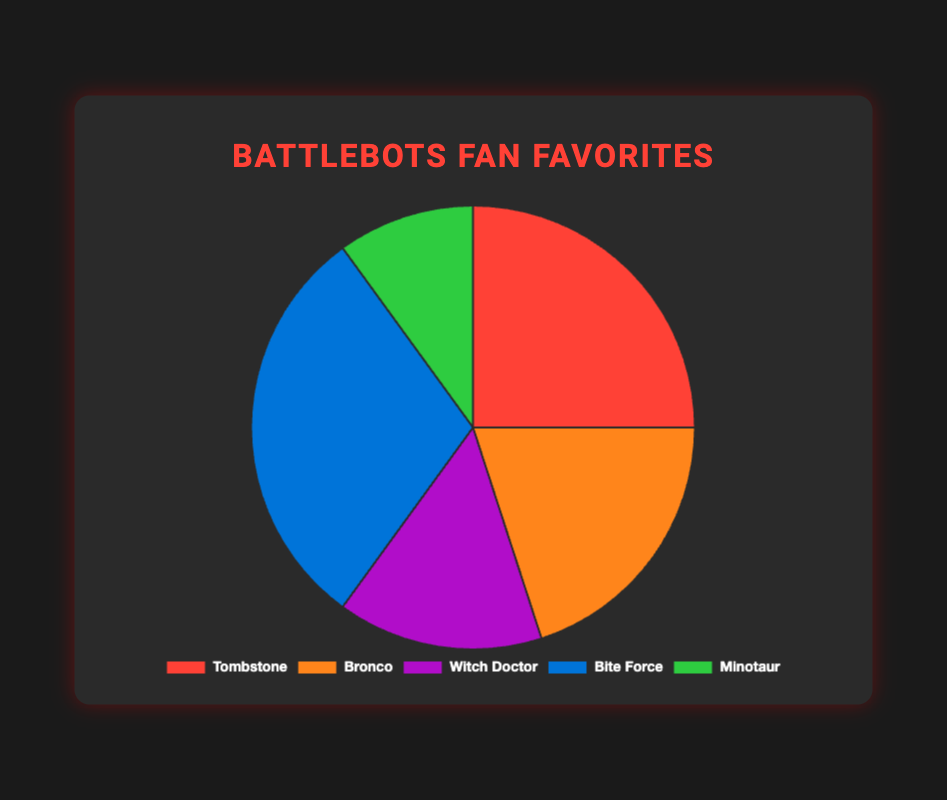what percentage of fans prefer Tombstone over Minotaur? Fans prefer Tombstone and Minotaur by 25% and 10% respectively. To find out how much more, subtract Minotaur's percentage from Tombstone's: 25% - 10% = 15%.
Answer: 15% Which bot is the most popular among fans? The bot with the highest percentage of fans is the most popular. From the data, Bite Force has the highest percentage at 30%.
Answer: Bite Force Which two bots together make up 45% of fan preferences? Adding the percentages of Witch Doctor (15%) and Bronco (20%) equals 35%. Combining Bronco (20%) with Minotaur (10%) equals 30%. The only two bots that sum to 45% are Witch Doctor and Tombstone (25% + 20%).
Answer: Tombstone and Bronco Is Bronco more popular than Witch Doctor and Minotaur combined? Calculate Witch Doctor and Minotaur's combined percentage: 15% + 10% = 25%. Since Bronco’s percentage is 20%, Bronco is less popular.
Answer: No If Witch Doctor and Minotaur were merged into a single bot, would it surpass Tombstone in popularity? Add their percentages: 15% + 10% = 25%. Tombstone also has 25% fans, so they would be equally popular.
Answer: No, they would be equal How many bots have a fan base greater than or equal to 20%? Identify bots with 20% or more: Tombstone (25%), Bite Force (30%), Bronco (20%). There are three such bots.
Answer: 3 What is the average percentage of fans for all bots? Sum up all percentages: 25 + 20 + 15 + 30 + 10 = 100. Divide by the number of bots: 100 / 5 = 20.
Answer: 20% Which bot is the least popular? The bot with the smallest percentage is the least popular. Minotaur has the lowest percentage at 10%.
Answer: Minotaur What is the combined percentage of fans for Tombstone, Witch Doctor, and Minotaur? Add the percentages for Tombstone (25%), Witch Doctor (15%), and Minotaur (10%): 25% + 15% + 10% = 50%.
Answer: 50% Do more fans prefer Bite Force or Witch Doctor and Bronco combined? Calculate Witch Doctor and Bronco’s combined percentage: 15% + 20% = 35%. Since Bite Force has 30%, Witch Doctor and Bronco combined are preferred by more fans.
Answer: Witch Doctor and Bronco combined 